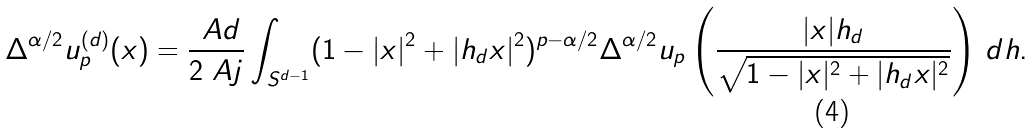<formula> <loc_0><loc_0><loc_500><loc_500>\Delta ^ { \alpha / 2 } u _ { p } ^ { ( d ) } ( x ) = \frac { \ A d } { 2 \ A j } \int _ { S ^ { d - 1 } } ( 1 - | x | ^ { 2 } + | h _ { d } x | ^ { 2 } ) ^ { p - \alpha / 2 } \Delta ^ { \alpha / 2 } u _ { p } \left ( \frac { | x | h _ { d } } { \sqrt { 1 - | x | ^ { 2 } + | h _ { d } x | ^ { 2 } } } \right ) \, d h .</formula> 